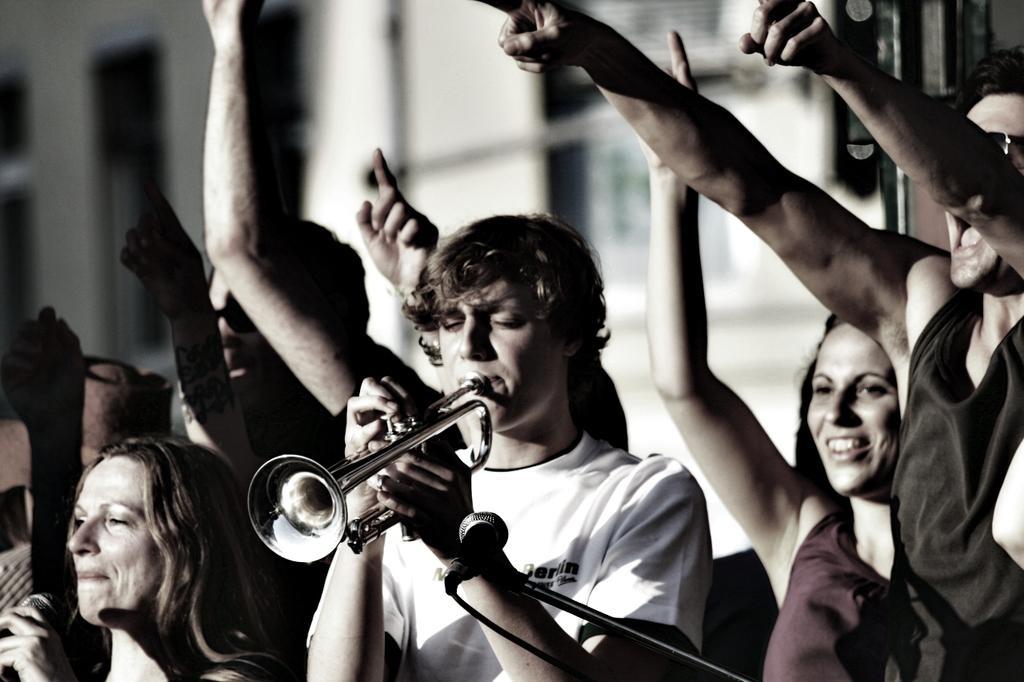In one or two sentences, can you explain what this image depicts? This picture is of outside. On the right there is a man and a woman smiling. In the center there is a man wearing white color t-shirt, playing trumpet and seems to be standing. We can see a microphone attached to the stand. On the left there are group of persons seems to be standing. In the background we can see the buildings. 